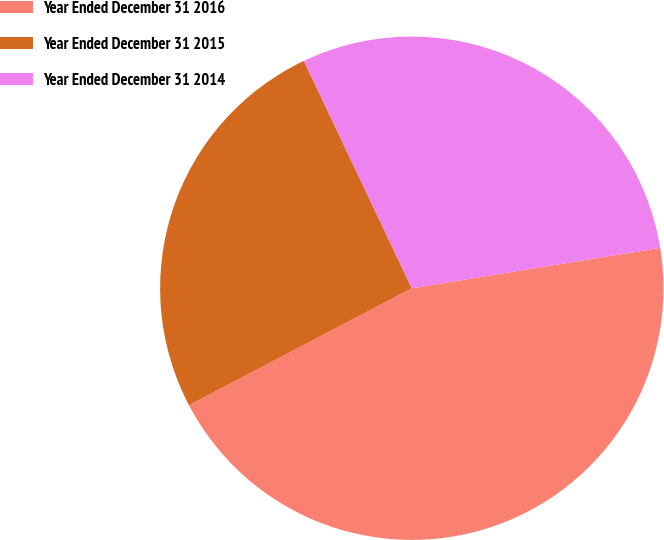<chart> <loc_0><loc_0><loc_500><loc_500><pie_chart><fcel>Year Ended December 31 2016<fcel>Year Ended December 31 2015<fcel>Year Ended December 31 2014<nl><fcel>44.87%<fcel>25.64%<fcel>29.49%<nl></chart> 